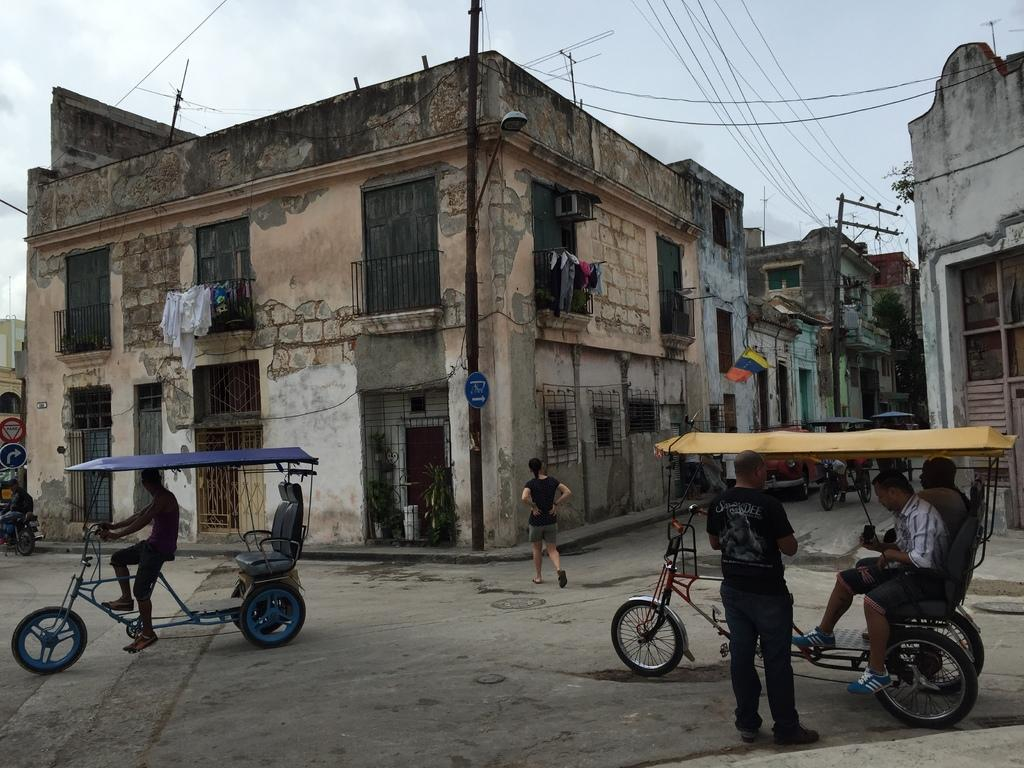What type of structures can be seen in the image? There are buildings in the image. What else is present in the image besides buildings? Electrical poles, wires, clothes, vehicles, people, and a path are visible in the image. Can you describe the sky in the image? The sky is visible in the background of the image, and it appears to be cloudy. How many types of objects are mentioned in the image? There are nine types of objects mentioned in the image: buildings, electrical poles, wires, clothes, vehicles, people, a path, and the sky. What type of cabbage is being used to make the soup in the image? There is no cabbage or soup present in the image. Can you describe the shape of the ear in the image? There is no ear present in the image. 